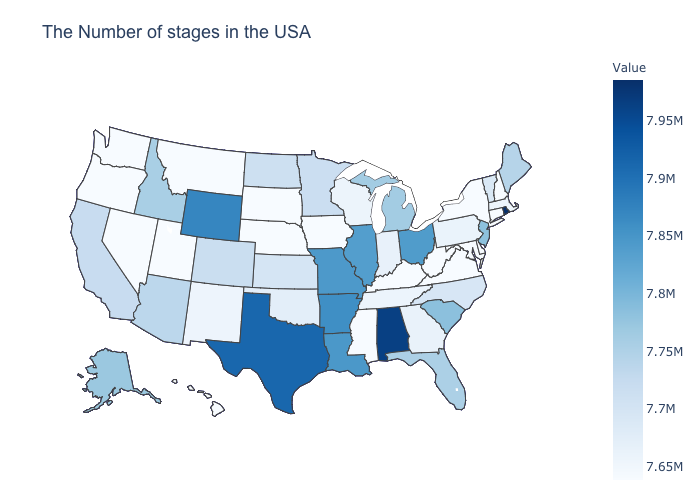Is the legend a continuous bar?
Be succinct. Yes. Does the map have missing data?
Short answer required. No. Among the states that border Virginia , which have the highest value?
Answer briefly. North Carolina. Does Nebraska have the lowest value in the USA?
Answer briefly. Yes. Does Maryland have the lowest value in the USA?
Give a very brief answer. Yes. Among the states that border New Mexico , which have the lowest value?
Short answer required. Utah. 